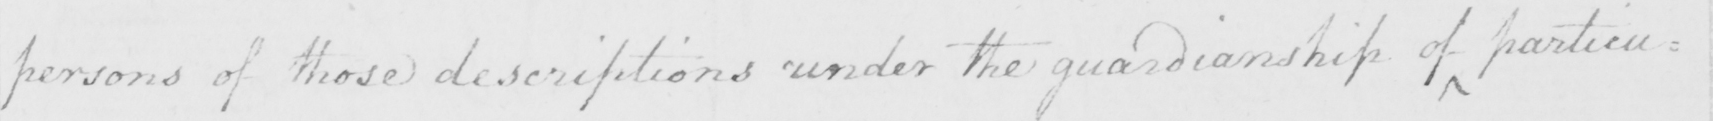What text is written in this handwritten line? persons of those descriptions under the guardianship of particu= 